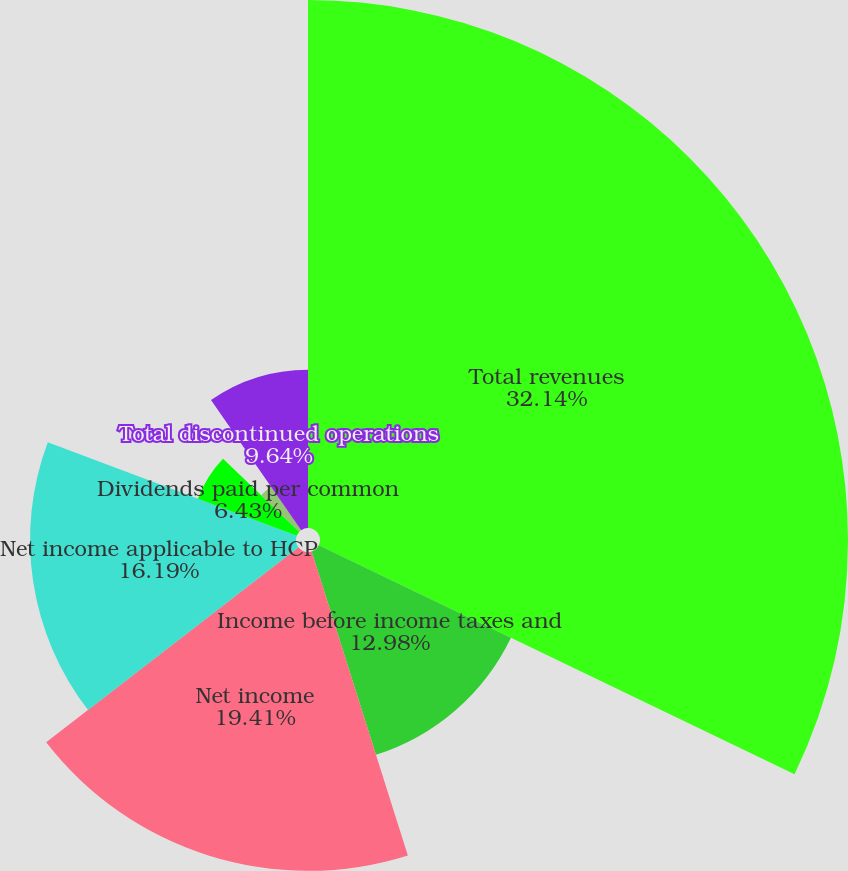Convert chart to OTSL. <chart><loc_0><loc_0><loc_500><loc_500><pie_chart><fcel>Total revenues<fcel>Income before income taxes and<fcel>Net income<fcel>Net income applicable to HCP<fcel>Dividends paid per common<fcel>Basic earnings per common<fcel>Diluted earnings per common<fcel>Total discontinued operations<nl><fcel>32.14%<fcel>12.98%<fcel>19.41%<fcel>16.19%<fcel>6.43%<fcel>0.0%<fcel>3.21%<fcel>9.64%<nl></chart> 